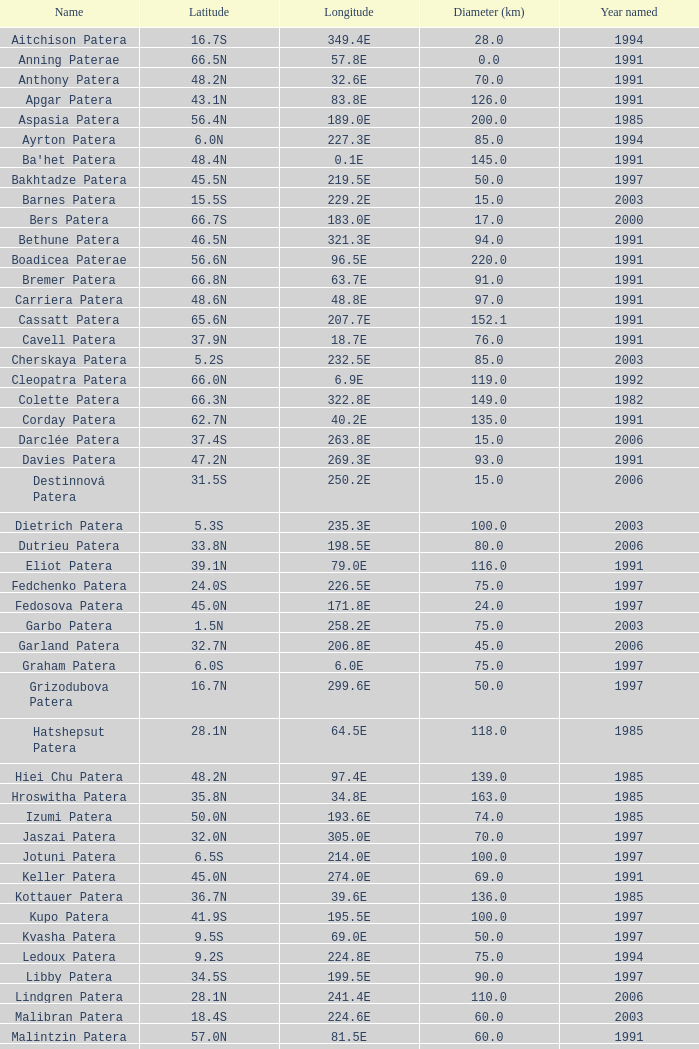What is Year Named, when Longitude is 227.5E? 1997.0. 